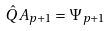Convert formula to latex. <formula><loc_0><loc_0><loc_500><loc_500>\hat { Q } A _ { p + 1 } = \Psi _ { p + 1 }</formula> 